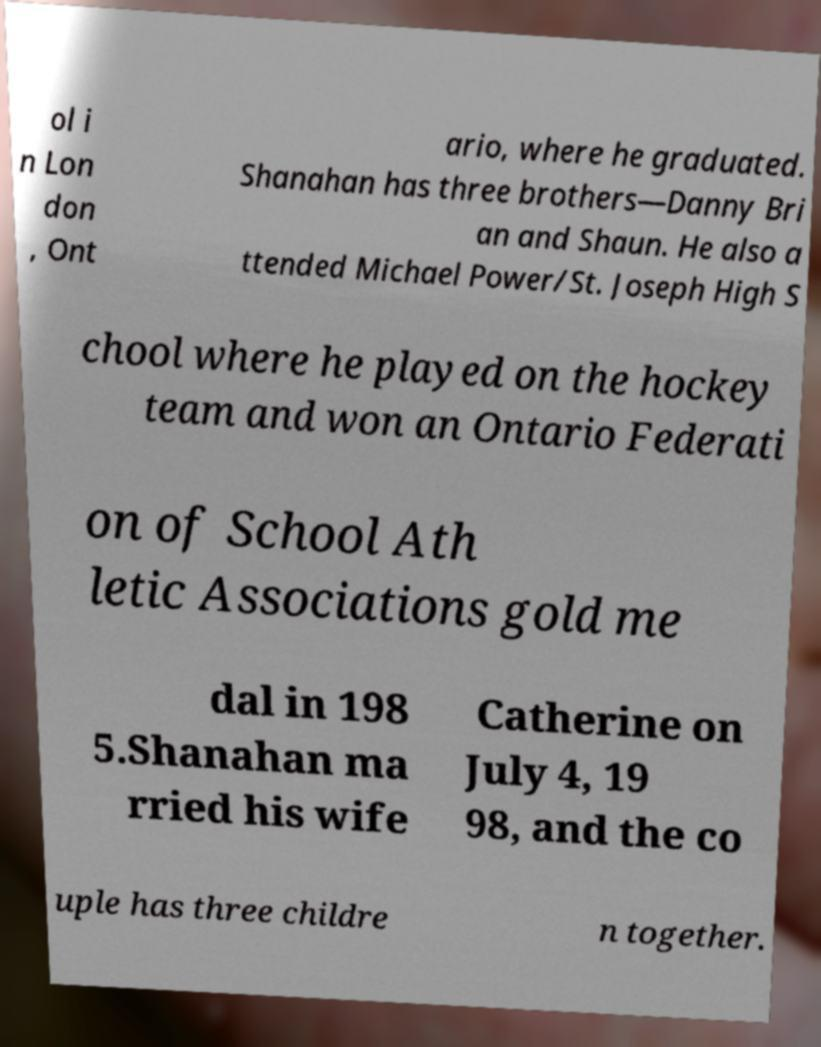Please identify and transcribe the text found in this image. ol i n Lon don , Ont ario, where he graduated. Shanahan has three brothers—Danny Bri an and Shaun. He also a ttended Michael Power/St. Joseph High S chool where he played on the hockey team and won an Ontario Federati on of School Ath letic Associations gold me dal in 198 5.Shanahan ma rried his wife Catherine on July 4, 19 98, and the co uple has three childre n together. 